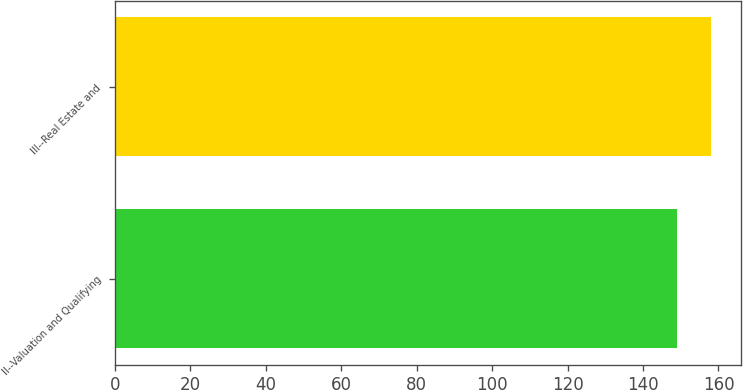Convert chart to OTSL. <chart><loc_0><loc_0><loc_500><loc_500><bar_chart><fcel>II--Valuation and Qualifying<fcel>III--Real Estate and<nl><fcel>149<fcel>158<nl></chart> 